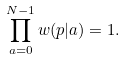<formula> <loc_0><loc_0><loc_500><loc_500>\prod _ { a = 0 } ^ { N - 1 } w ( p | a ) = 1 .</formula> 